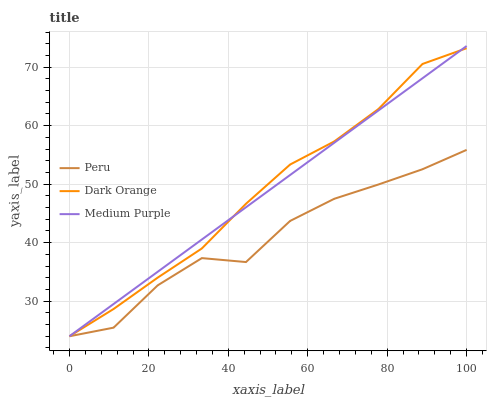Does Peru have the minimum area under the curve?
Answer yes or no. Yes. Does Dark Orange have the maximum area under the curve?
Answer yes or no. Yes. Does Dark Orange have the minimum area under the curve?
Answer yes or no. No. Does Peru have the maximum area under the curve?
Answer yes or no. No. Is Medium Purple the smoothest?
Answer yes or no. Yes. Is Peru the roughest?
Answer yes or no. Yes. Is Dark Orange the smoothest?
Answer yes or no. No. Is Dark Orange the roughest?
Answer yes or no. No. Does Medium Purple have the lowest value?
Answer yes or no. Yes. Does Medium Purple have the highest value?
Answer yes or no. Yes. Does Dark Orange have the highest value?
Answer yes or no. No. Does Medium Purple intersect Dark Orange?
Answer yes or no. Yes. Is Medium Purple less than Dark Orange?
Answer yes or no. No. Is Medium Purple greater than Dark Orange?
Answer yes or no. No. 